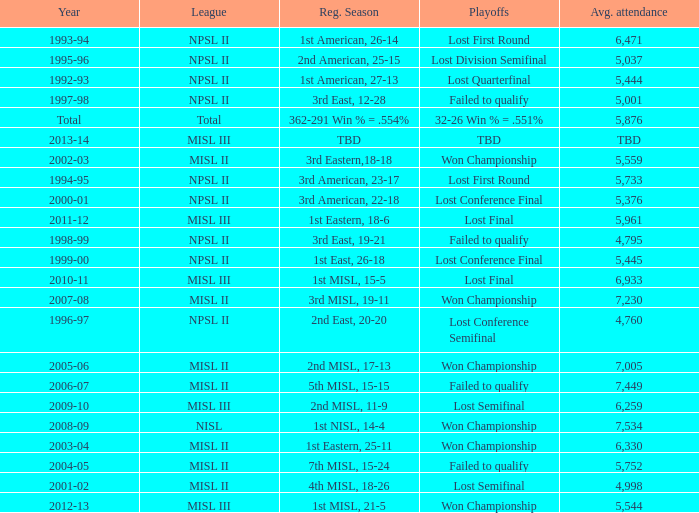In 2010-11, what was the League name? MISL III. 